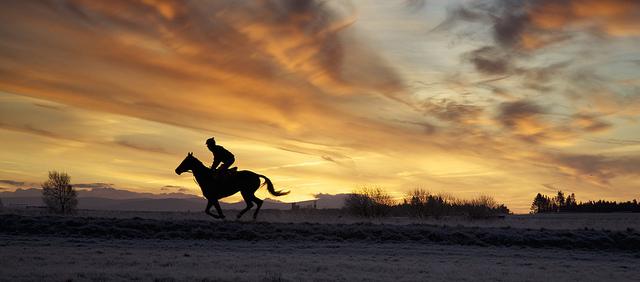What style of riding is this?
Short answer required. Horseback. Where is the horse?
Concise answer only. Left. How many real live dogs are in the photo?
Quick response, please. 0. Is it sunset?
Quick response, please. Yes. 